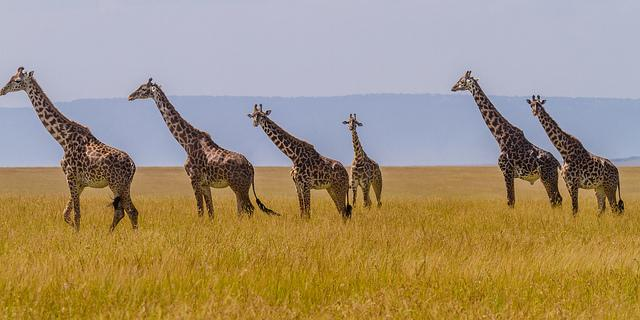How many giraffes are standing up? six 